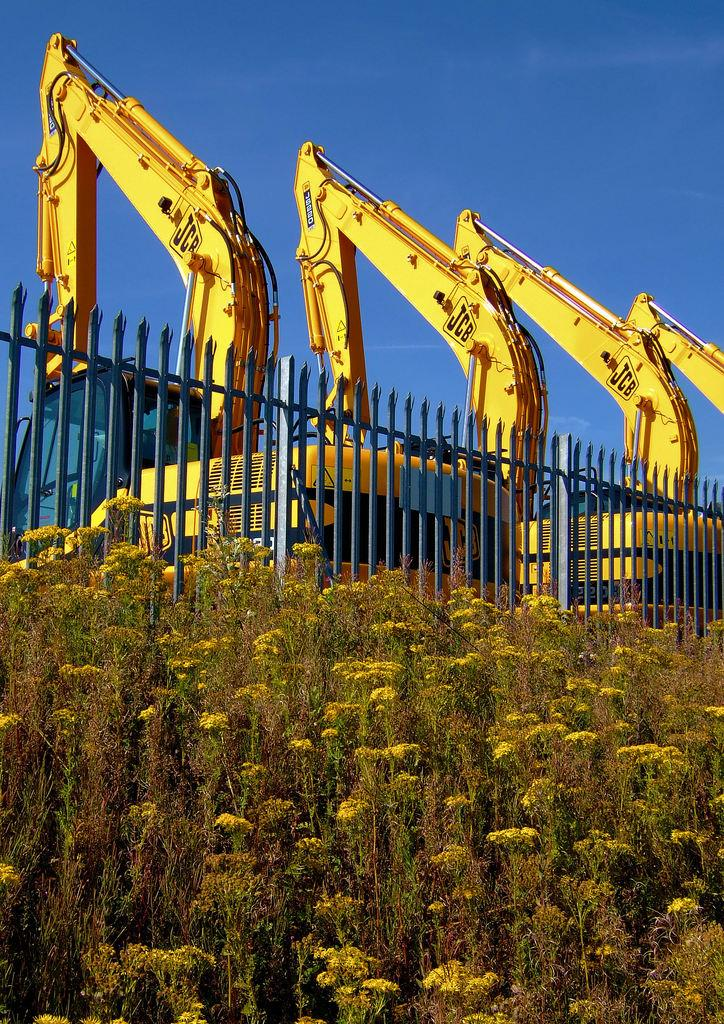What can be seen in the image that has wheels and is used for transportation? There are vehicles in the image. What is in front of the vehicles in the image? There is a fence and a group of plants in front of the vehicles. What is visible at the top of the image? The sky is visible at the top of the image. Where is the flame coming from in the image? There is no flame present in the image. What type of muscle can be seen flexing in the image? There are no muscles visible in the image. 